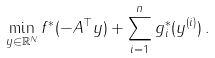Convert formula to latex. <formula><loc_0><loc_0><loc_500><loc_500>\min _ { y \in \mathbb { R } ^ { N } } f ^ { * } ( - A ^ { \top } y ) + \sum _ { i = 1 } ^ { n } g ^ { * } _ { i } ( y ^ { ( i ) } ) \, .</formula> 